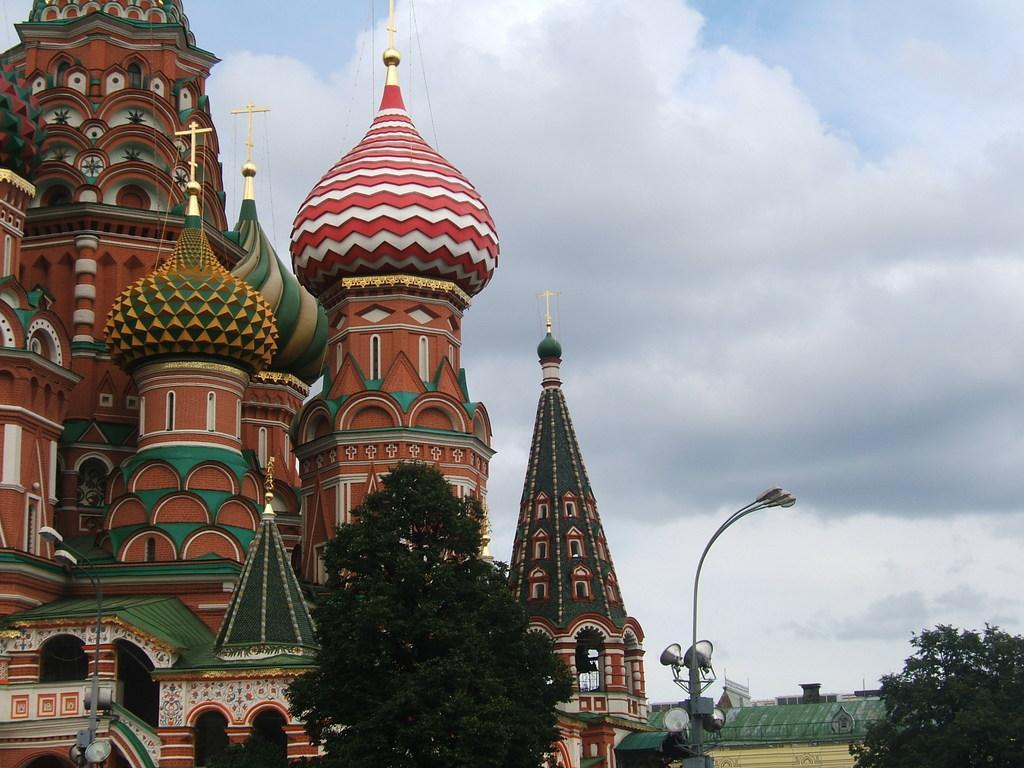In one or two sentences, can you explain what this image depicts? In this picture we can see few buildings, trees, poles and clouds. 